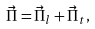<formula> <loc_0><loc_0><loc_500><loc_500>\vec { \Pi } = \vec { \Pi } _ { l } + \vec { \Pi } _ { t } ,</formula> 